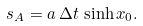Convert formula to latex. <formula><loc_0><loc_0><loc_500><loc_500>s _ { A } = a \, \Delta t \, \sinh x _ { 0 } .</formula> 